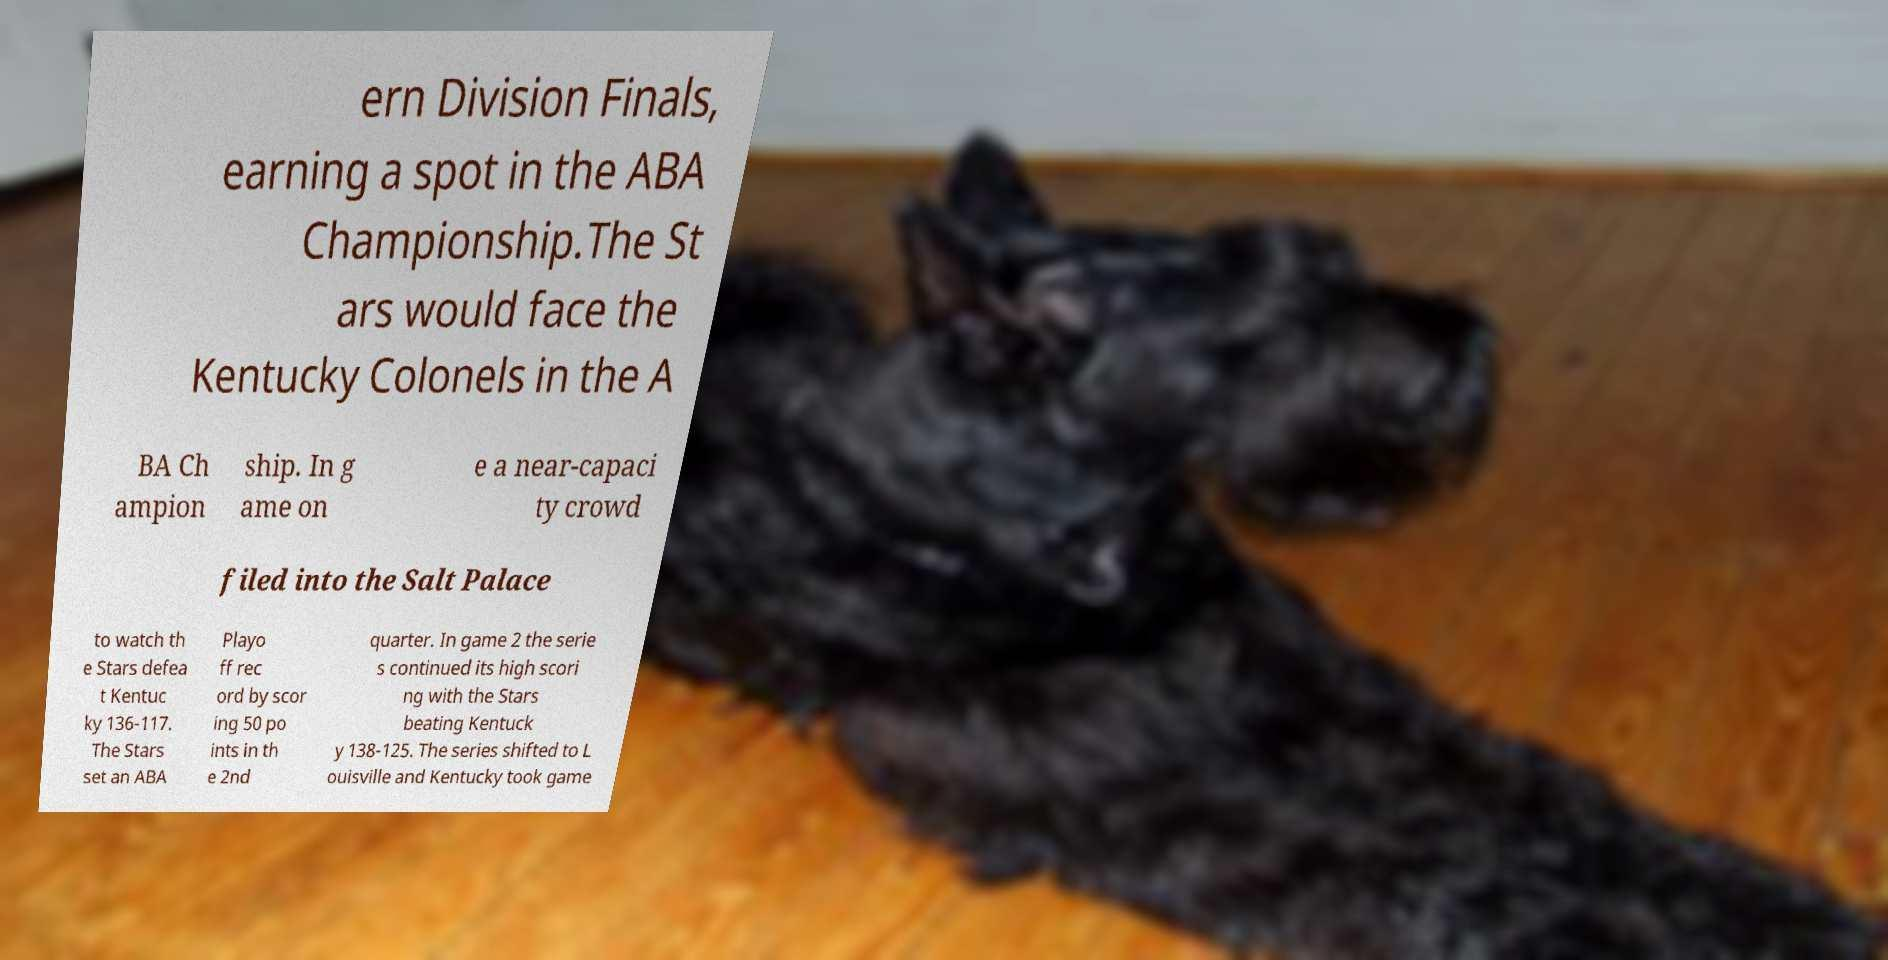There's text embedded in this image that I need extracted. Can you transcribe it verbatim? ern Division Finals, earning a spot in the ABA Championship.The St ars would face the Kentucky Colonels in the A BA Ch ampion ship. In g ame on e a near-capaci ty crowd filed into the Salt Palace to watch th e Stars defea t Kentuc ky 136-117. The Stars set an ABA Playo ff rec ord by scor ing 50 po ints in th e 2nd quarter. In game 2 the serie s continued its high scori ng with the Stars beating Kentuck y 138-125. The series shifted to L ouisville and Kentucky took game 